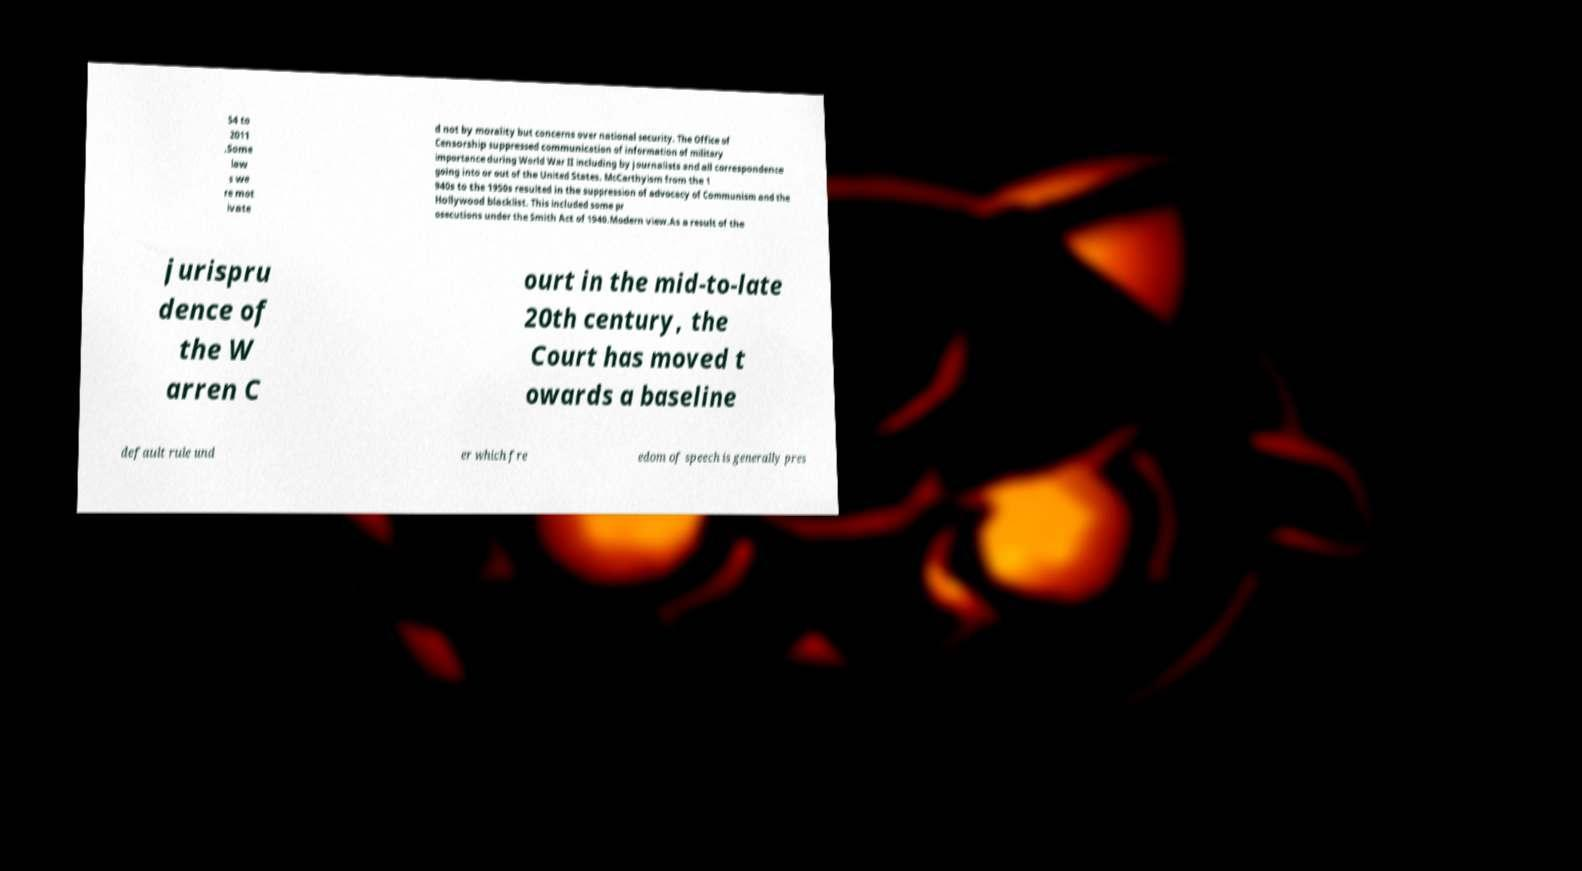Can you accurately transcribe the text from the provided image for me? 54 to 2011 .Some law s we re mot ivate d not by morality but concerns over national security. The Office of Censorship suppressed communication of information of military importance during World War II including by journalists and all correspondence going into or out of the United States. McCarthyism from the 1 940s to the 1950s resulted in the suppression of advocacy of Communism and the Hollywood blacklist. This included some pr osecutions under the Smith Act of 1940.Modern view.As a result of the jurispru dence of the W arren C ourt in the mid-to-late 20th century, the Court has moved t owards a baseline default rule und er which fre edom of speech is generally pres 